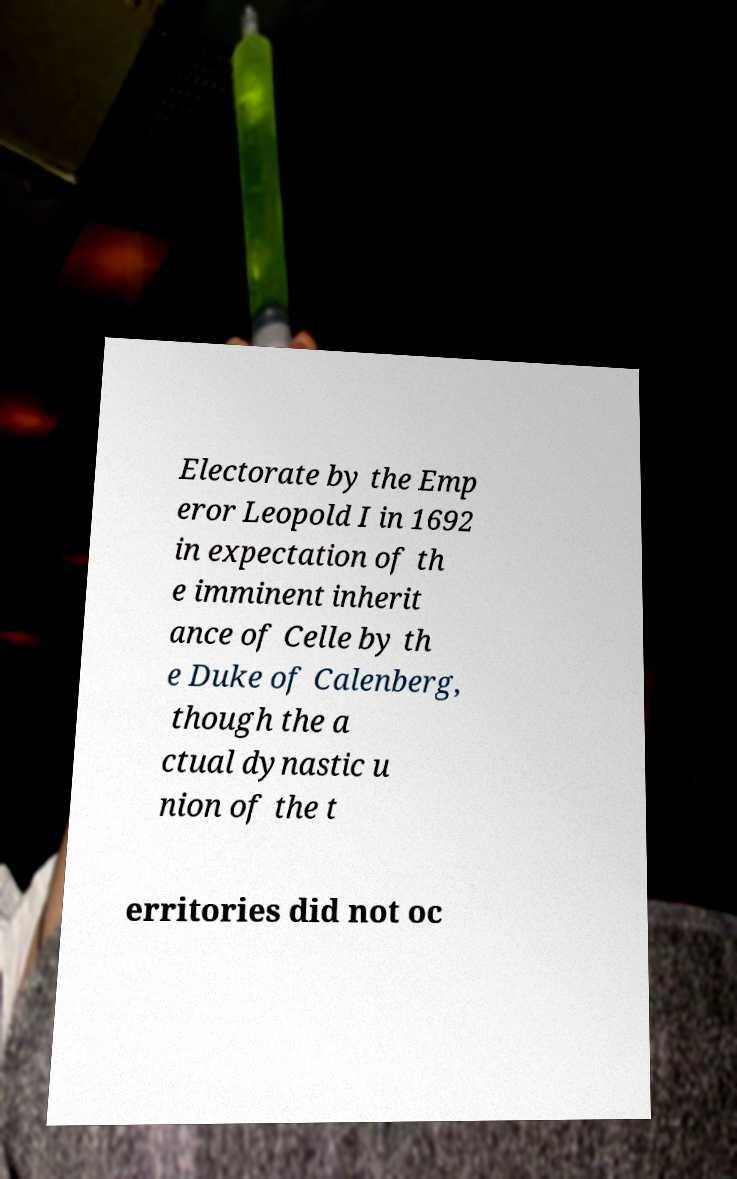Please read and relay the text visible in this image. What does it say? Electorate by the Emp eror Leopold I in 1692 in expectation of th e imminent inherit ance of Celle by th e Duke of Calenberg, though the a ctual dynastic u nion of the t erritories did not oc 